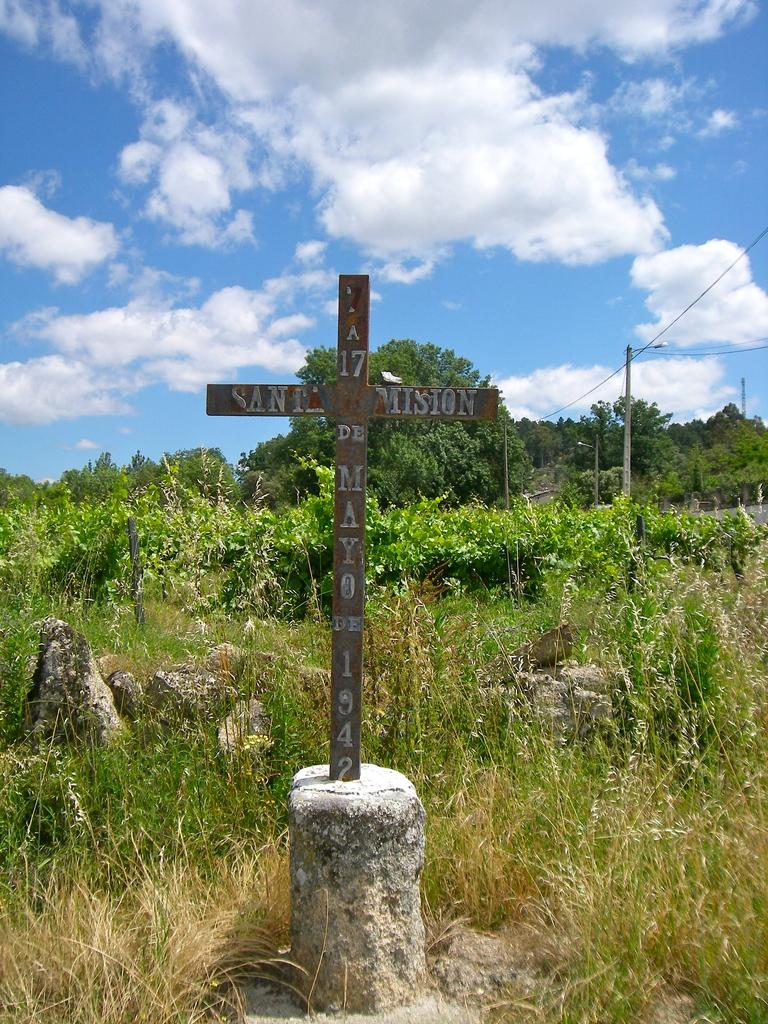What religious symbol can be seen in the image? There is a cross in the image. What type of natural objects are present in the image? There are stones and trees in the image. What man-made object can be seen in the image? There is a pole in the image. What can be seen in the background of the image? The sky with clouds is visible in the background of the image. How much wealth is represented by the stones in the image? The image does not provide any information about the value or wealth associated with the stones. Can you tell me how many dogs are present in the image? There are no dogs present in the image. 